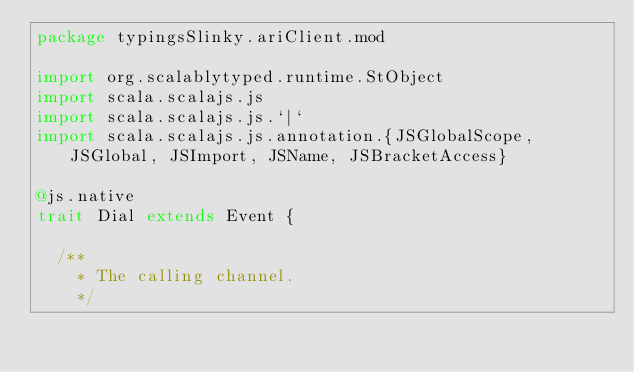<code> <loc_0><loc_0><loc_500><loc_500><_Scala_>package typingsSlinky.ariClient.mod

import org.scalablytyped.runtime.StObject
import scala.scalajs.js
import scala.scalajs.js.`|`
import scala.scalajs.js.annotation.{JSGlobalScope, JSGlobal, JSImport, JSName, JSBracketAccess}

@js.native
trait Dial extends Event {
  
  /**
    * The calling channel.
    */</code> 